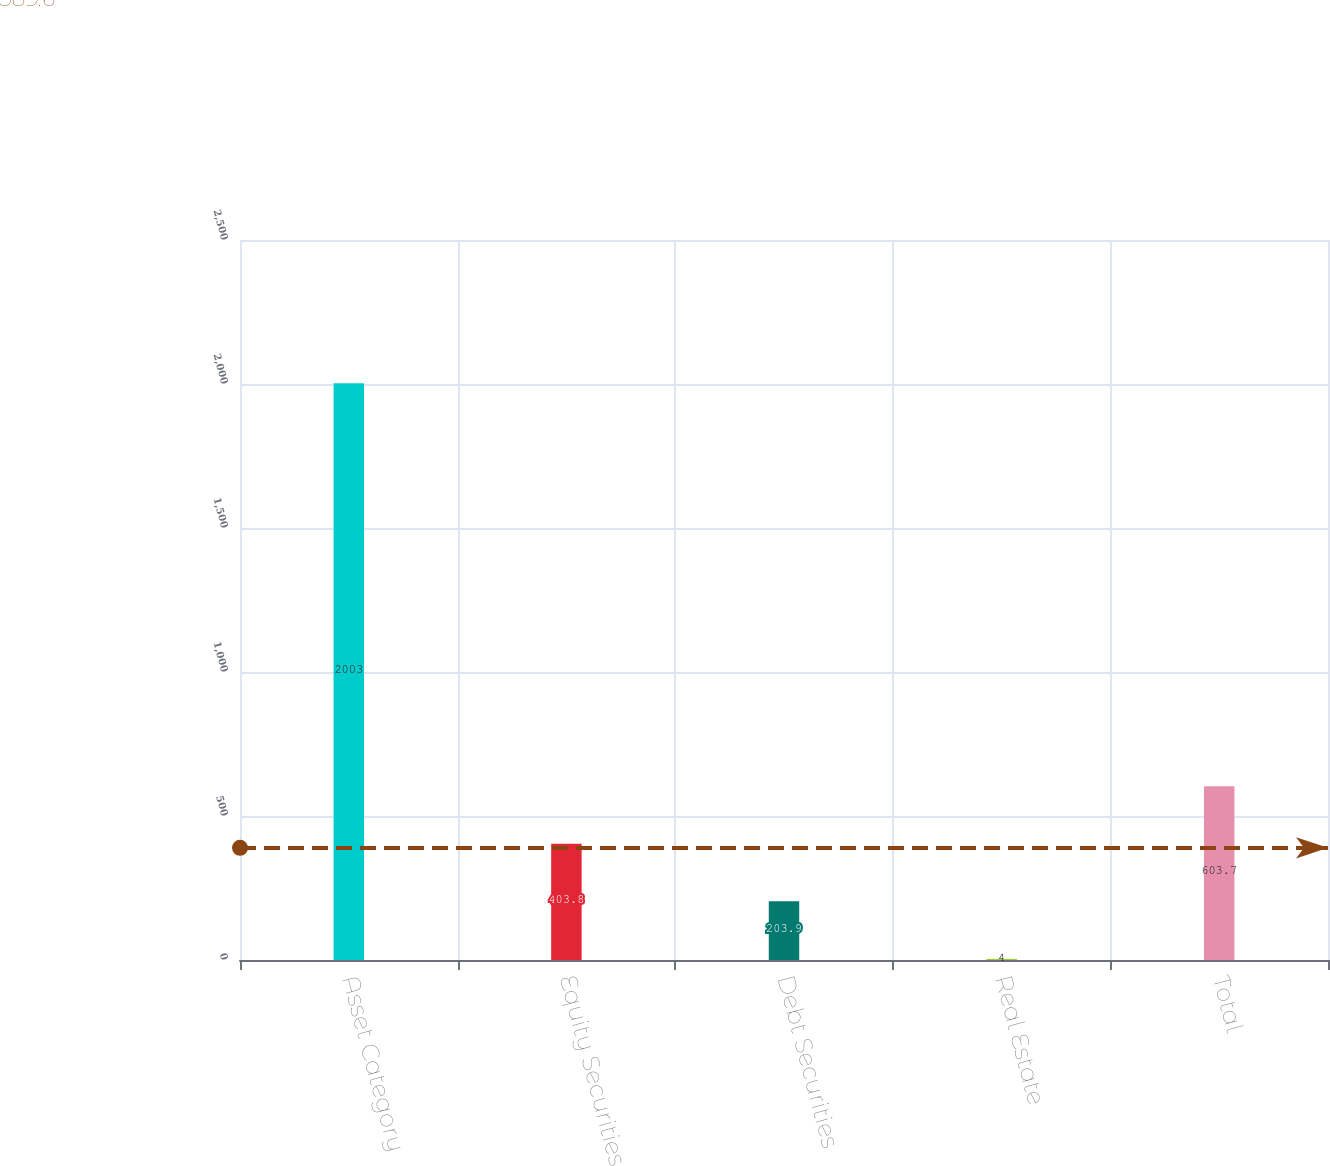<chart> <loc_0><loc_0><loc_500><loc_500><bar_chart><fcel>Asset Category<fcel>Equity Securities<fcel>Debt Securities<fcel>Real Estate<fcel>Total<nl><fcel>2003<fcel>403.8<fcel>203.9<fcel>4<fcel>603.7<nl></chart> 